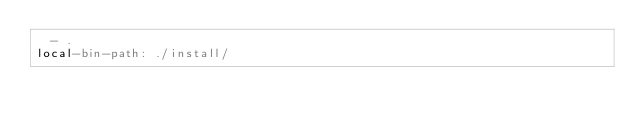<code> <loc_0><loc_0><loc_500><loc_500><_YAML_>  - .
local-bin-path: ./install/
</code> 